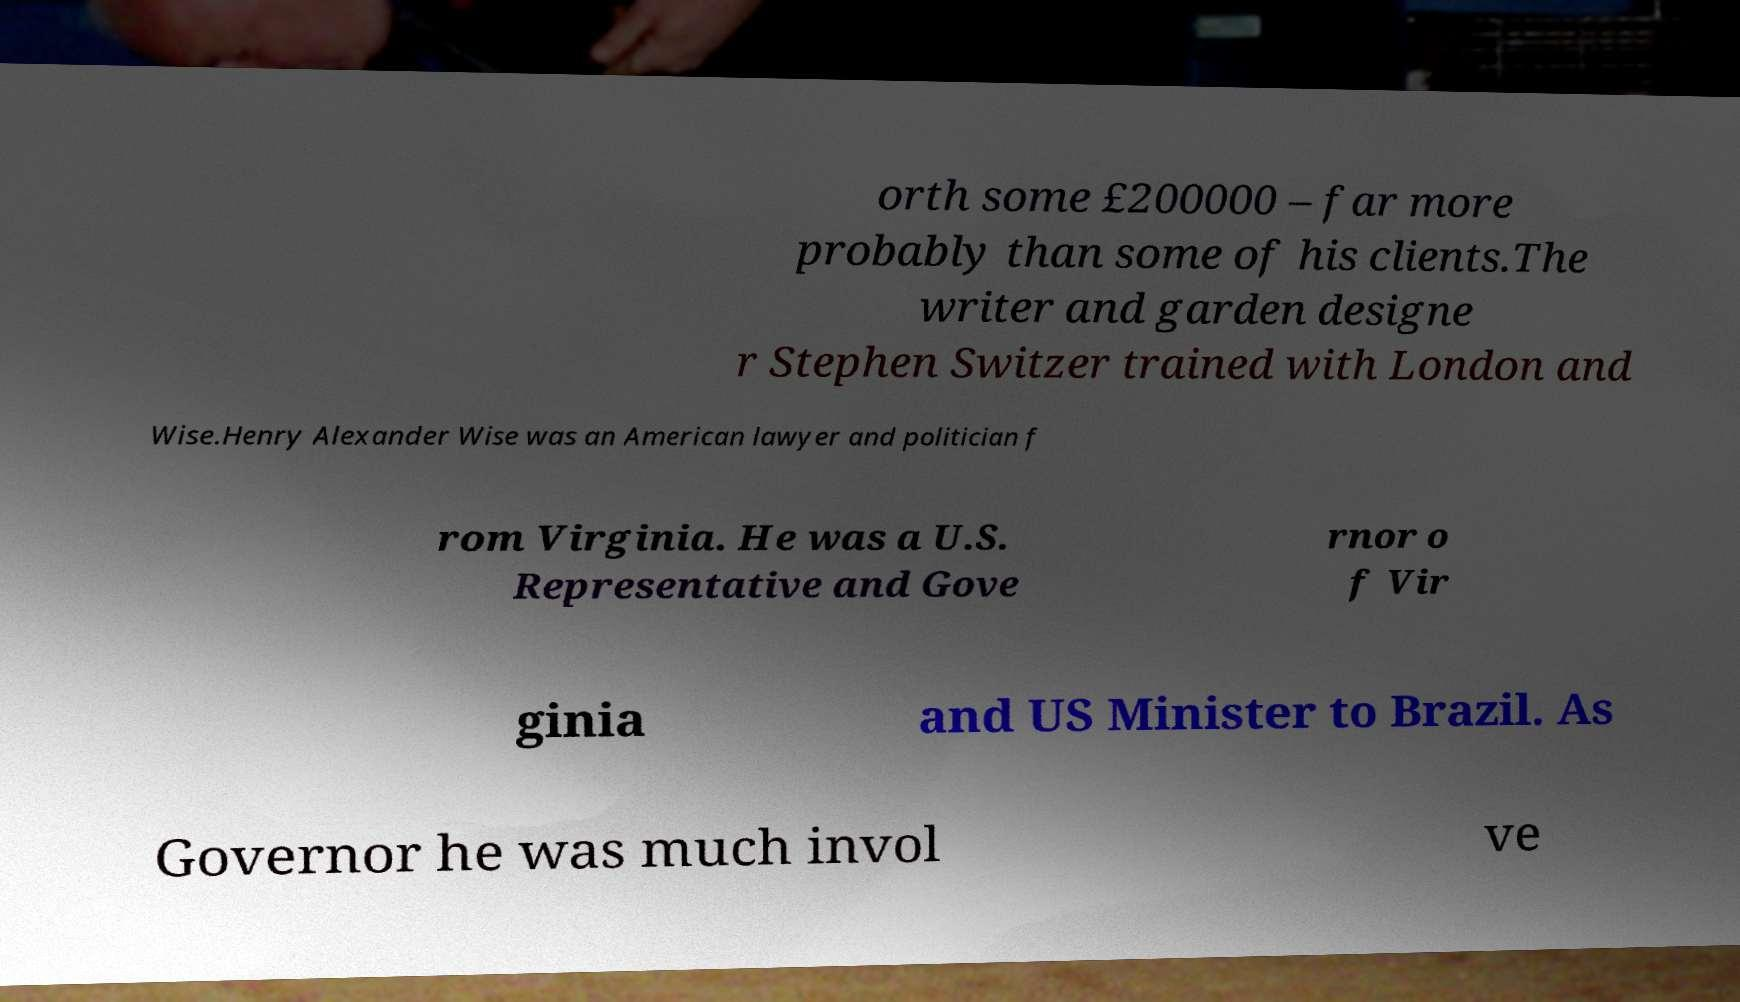Can you accurately transcribe the text from the provided image for me? orth some £200000 – far more probably than some of his clients.The writer and garden designe r Stephen Switzer trained with London and Wise.Henry Alexander Wise was an American lawyer and politician f rom Virginia. He was a U.S. Representative and Gove rnor o f Vir ginia and US Minister to Brazil. As Governor he was much invol ve 